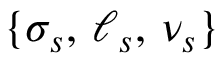<formula> <loc_0><loc_0><loc_500><loc_500>\{ \sigma _ { s } , \, \ell _ { s } , \, \nu _ { s } \}</formula> 